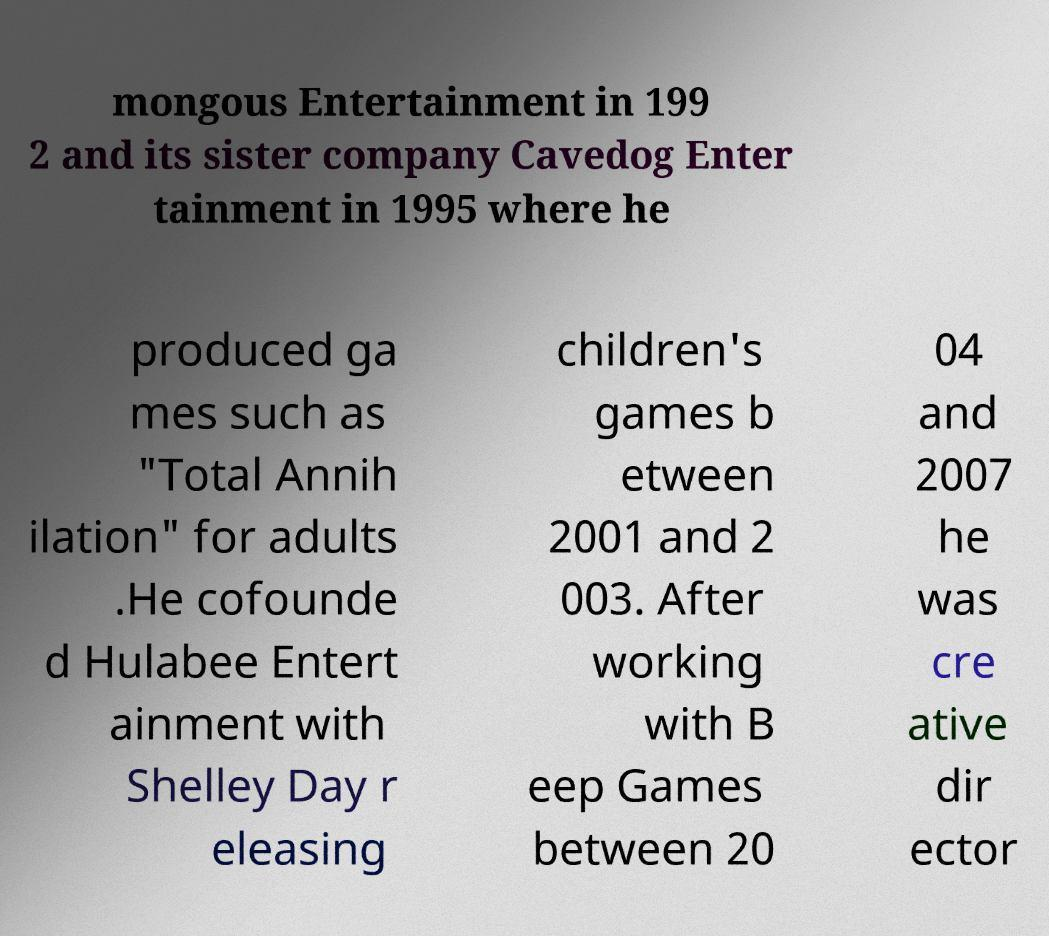Could you extract and type out the text from this image? mongous Entertainment in 199 2 and its sister company Cavedog Enter tainment in 1995 where he produced ga mes such as "Total Annih ilation" for adults .He cofounde d Hulabee Entert ainment with Shelley Day r eleasing children's games b etween 2001 and 2 003. After working with B eep Games between 20 04 and 2007 he was cre ative dir ector 